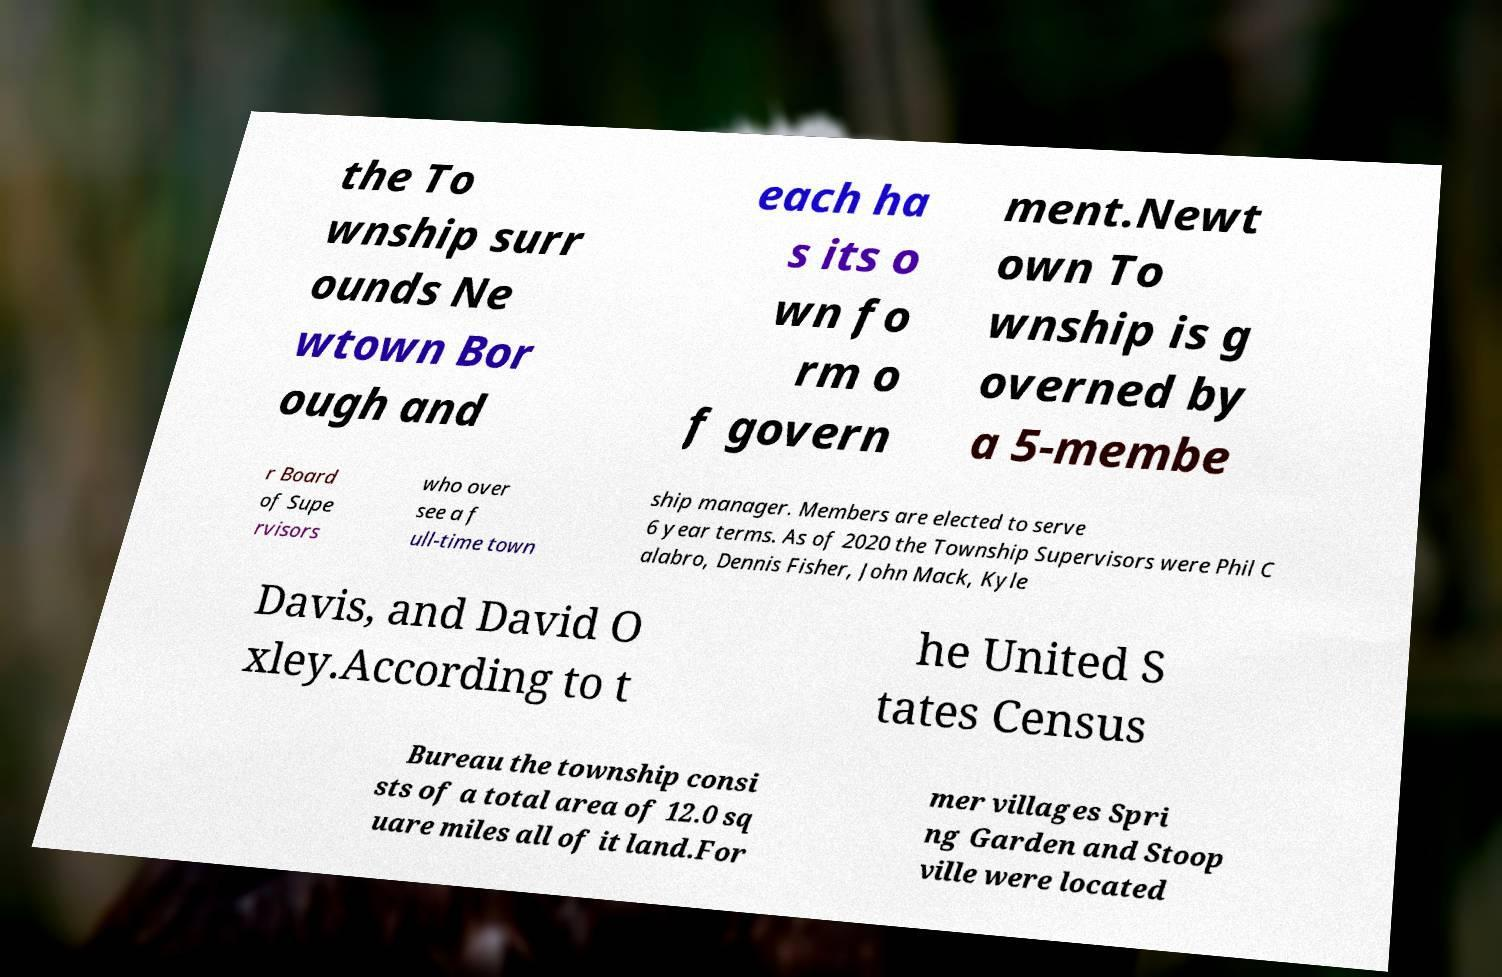Could you assist in decoding the text presented in this image and type it out clearly? the To wnship surr ounds Ne wtown Bor ough and each ha s its o wn fo rm o f govern ment.Newt own To wnship is g overned by a 5-membe r Board of Supe rvisors who over see a f ull-time town ship manager. Members are elected to serve 6 year terms. As of 2020 the Township Supervisors were Phil C alabro, Dennis Fisher, John Mack, Kyle Davis, and David O xley.According to t he United S tates Census Bureau the township consi sts of a total area of 12.0 sq uare miles all of it land.For mer villages Spri ng Garden and Stoop ville were located 